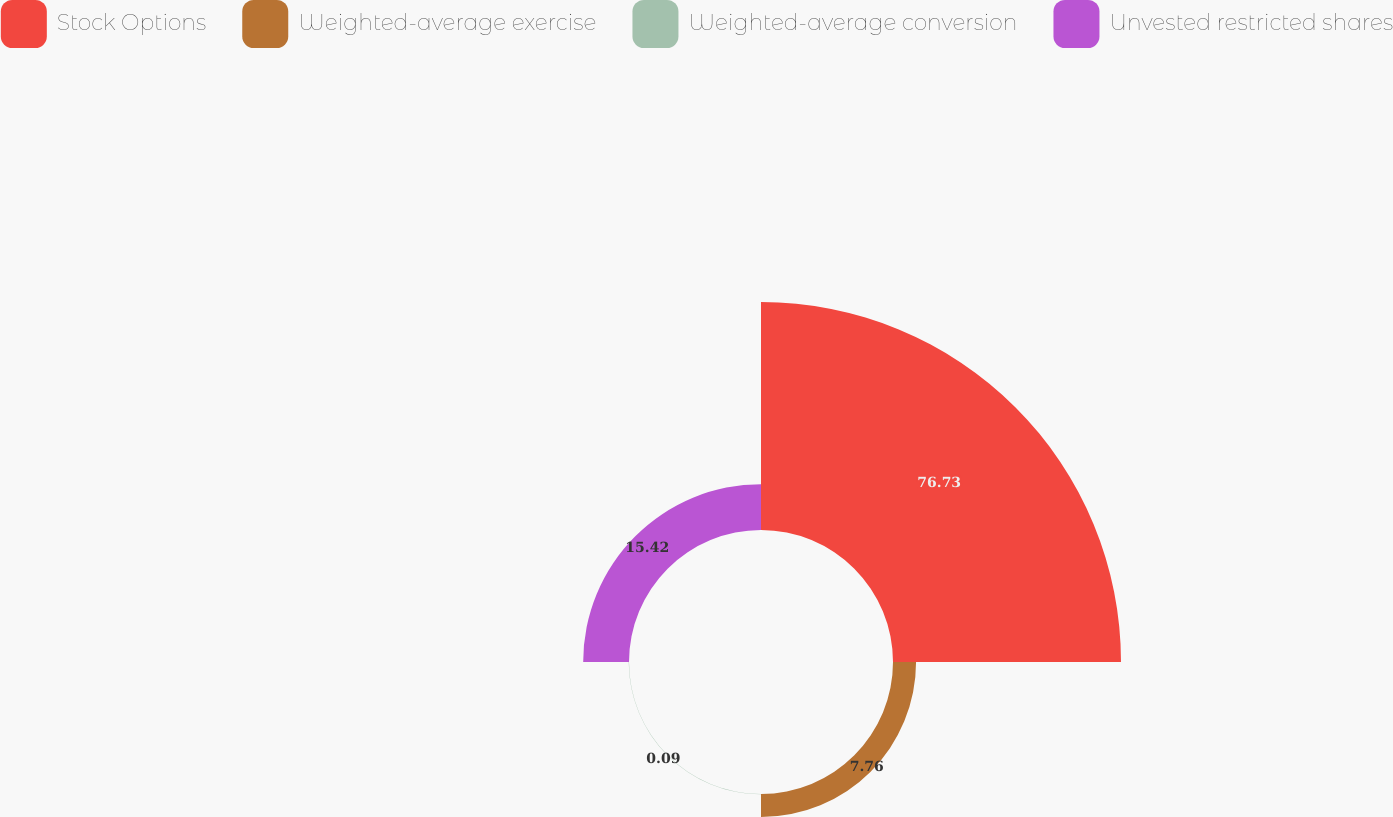Convert chart to OTSL. <chart><loc_0><loc_0><loc_500><loc_500><pie_chart><fcel>Stock Options<fcel>Weighted-average exercise<fcel>Weighted-average conversion<fcel>Unvested restricted shares<nl><fcel>76.73%<fcel>7.76%<fcel>0.09%<fcel>15.42%<nl></chart> 